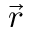Convert formula to latex. <formula><loc_0><loc_0><loc_500><loc_500>\vec { r }</formula> 